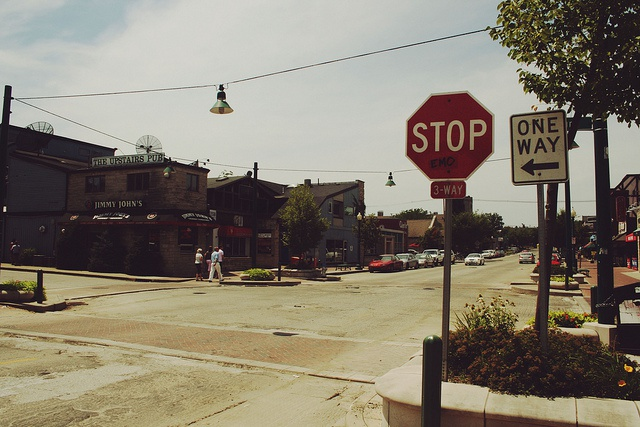Describe the objects in this image and their specific colors. I can see stop sign in darkgray, maroon, tan, gray, and black tones, car in darkgray, black, maroon, gray, and brown tones, people in darkgray and gray tones, people in darkgray, black, maroon, and gray tones, and car in darkgray, gray, and black tones in this image. 